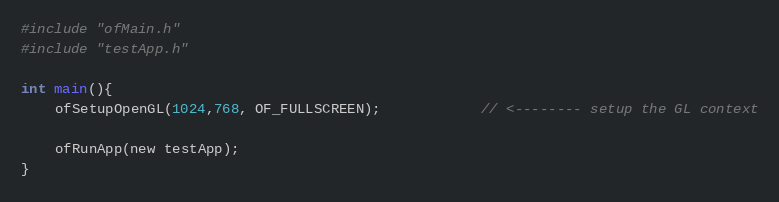Convert code to text. <code><loc_0><loc_0><loc_500><loc_500><_ObjectiveC_>#include "ofMain.h"
#include "testApp.h"

int main(){
	ofSetupOpenGL(1024,768, OF_FULLSCREEN);			// <-------- setup the GL context

	ofRunApp(new testApp);
}
</code> 